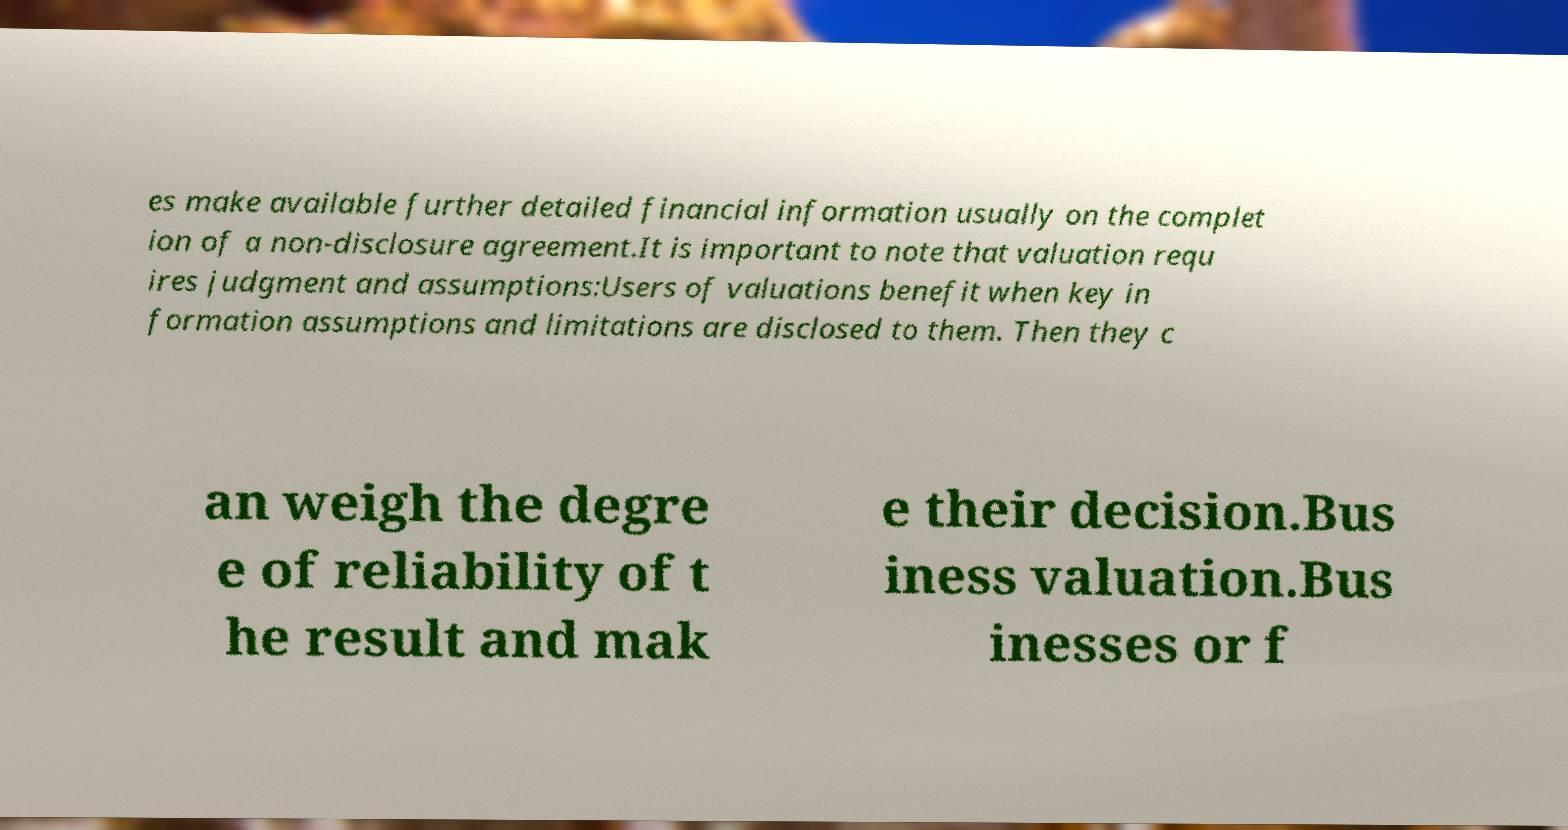Can you read and provide the text displayed in the image?This photo seems to have some interesting text. Can you extract and type it out for me? es make available further detailed financial information usually on the complet ion of a non-disclosure agreement.It is important to note that valuation requ ires judgment and assumptions:Users of valuations benefit when key in formation assumptions and limitations are disclosed to them. Then they c an weigh the degre e of reliability of t he result and mak e their decision.Bus iness valuation.Bus inesses or f 